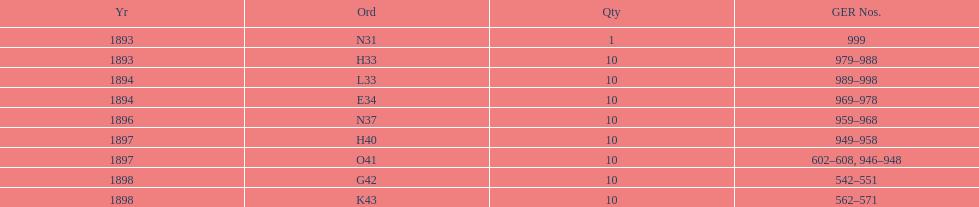What is the total number of locomotives made during this time? 81. 